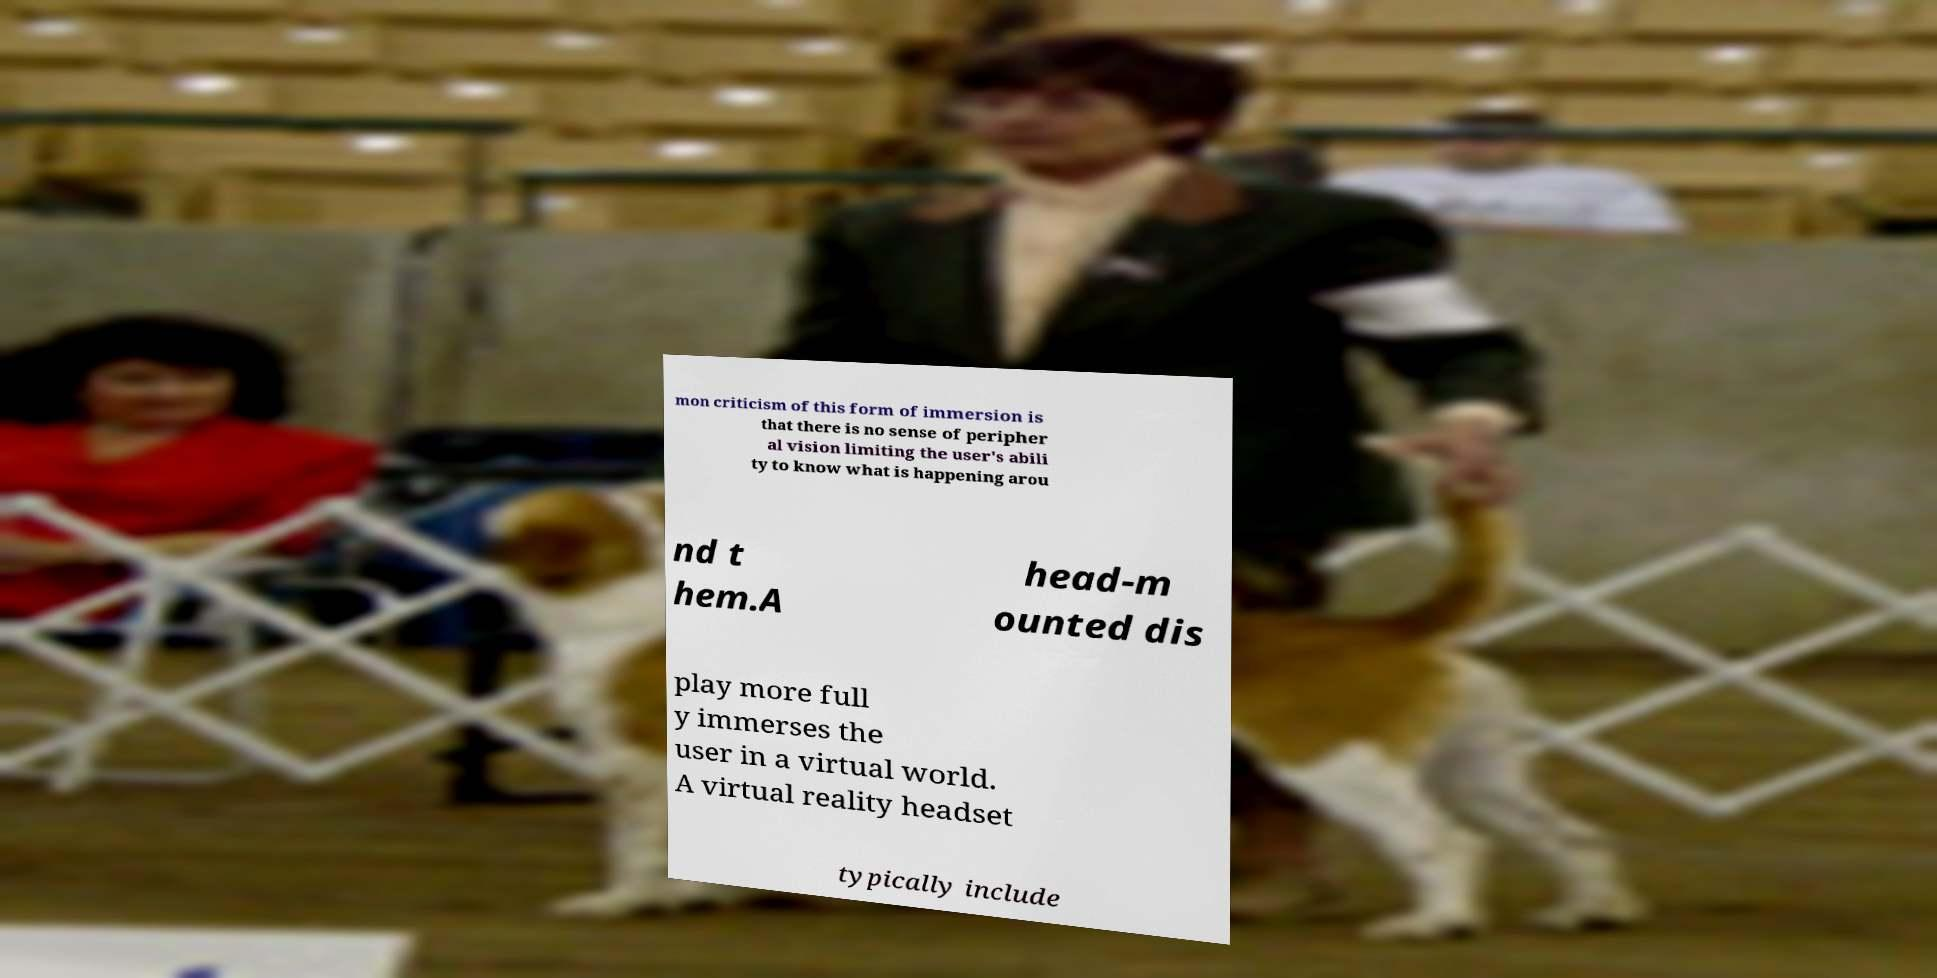Please read and relay the text visible in this image. What does it say? mon criticism of this form of immersion is that there is no sense of peripher al vision limiting the user's abili ty to know what is happening arou nd t hem.A head-m ounted dis play more full y immerses the user in a virtual world. A virtual reality headset typically include 